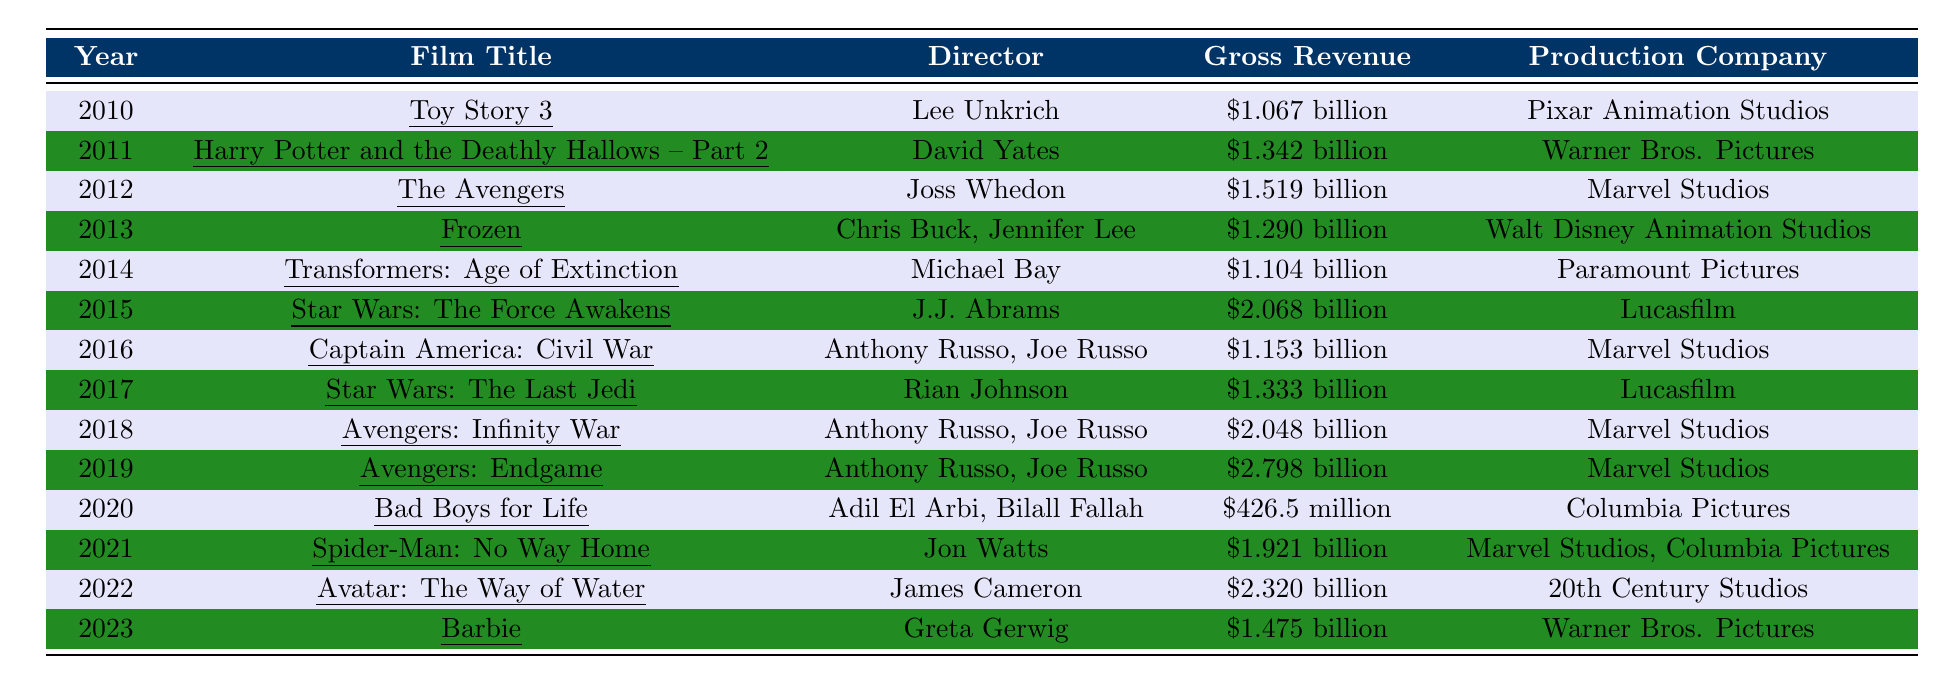What is the highest grossing film from 2015 to 2023? The highest grossing film in this range is "Avatar: The Way of Water," which earned $2.320 billion in gross revenue.
Answer: Avatar: The Way of Water Which film had the lowest gross revenue in 2020? The film with the lowest gross revenue in 2020 is "Bad Boys for Life," which grossed $426.5 million.
Answer: Bad Boys for Life How much more did "Avengers: Endgame" earn compared to "Star Wars: The Last Jedi"? "Avengers: Endgame" earned $2.798 billion while "Star Wars: The Last Jedi" grossed $1.333 billion. The difference is $2.798 billion - $1.333 billion = $1.465 billion.
Answer: $1.465 billion Which two films from the table earned over $2 billion? The two films that earned over $2 billion are "Star Wars: The Force Awakens" with $2.068 billion and "Avengers: Endgame" with $2.798 billion.
Answer: Star Wars: The Force Awakens and Avengers: Endgame What was the average gross revenue of the films from 2010 to 2014? The gross revenues for films from 2010 to 2014 are: Toy Story 3 ($1.067B), Harry Potter and the Deathly Hallows – Part 2 ($1.342B), The Avengers ($1.519B), Frozen ($1.290B), Transformers: Age of Extinction ($1.104B). The total revenue is $1.067B + $1.342B + $1.519B + $1.290B + $1.104B = $6.322 billion. There are 5 films, so the average is $6.322 billion / 5 = $1.2644 billion.
Answer: $1.2644 billion Did any film produced by Marvel Studios ever gross over $2 billion? Yes, both "Avengers: Infinity War" and "Avengers: Endgame," which were produced by Marvel Studios, grossed over $2 billion ($2.048 billion and $2.798 billion respectively).
Answer: Yes Which year had the highest grossing film and what was its title? The year with the highest grossing film is 2019, with "Avengers: Endgame," which grossed $2.798 billion.
Answer: 2019, Avengers: Endgame How does the gross revenue of "Spider-Man: No Way Home" compare to "Toy Story 3"? "Spider-Man: No Way Home" grossed $1.921 billion, while "Toy Story 3" grossed $1.067 billion. The difference in their gross revenues is $1.921 billion - $1.067 billion = $0.854 billion.
Answer: $0.854 billion Which film directed by a female director grossed the highest total? The film directed by a female director that grossed the highest is "Barbie," directed by Greta Gerwig, which earned $1.475 billion.
Answer: Barbie How many films in the table grossed more than $1.5 billion? There are four films that grossed more than $1.5 billion: "The Avengers," "Star Wars: The Force Awakens," "Avengers: Infinity War," and "Avengers: Endgame."
Answer: Four films In which year did "Frozen" release and what was its gross revenue? "Frozen" was released in 2013 and grossed $1.290 billion.
Answer: 2013, $1.290 billion 